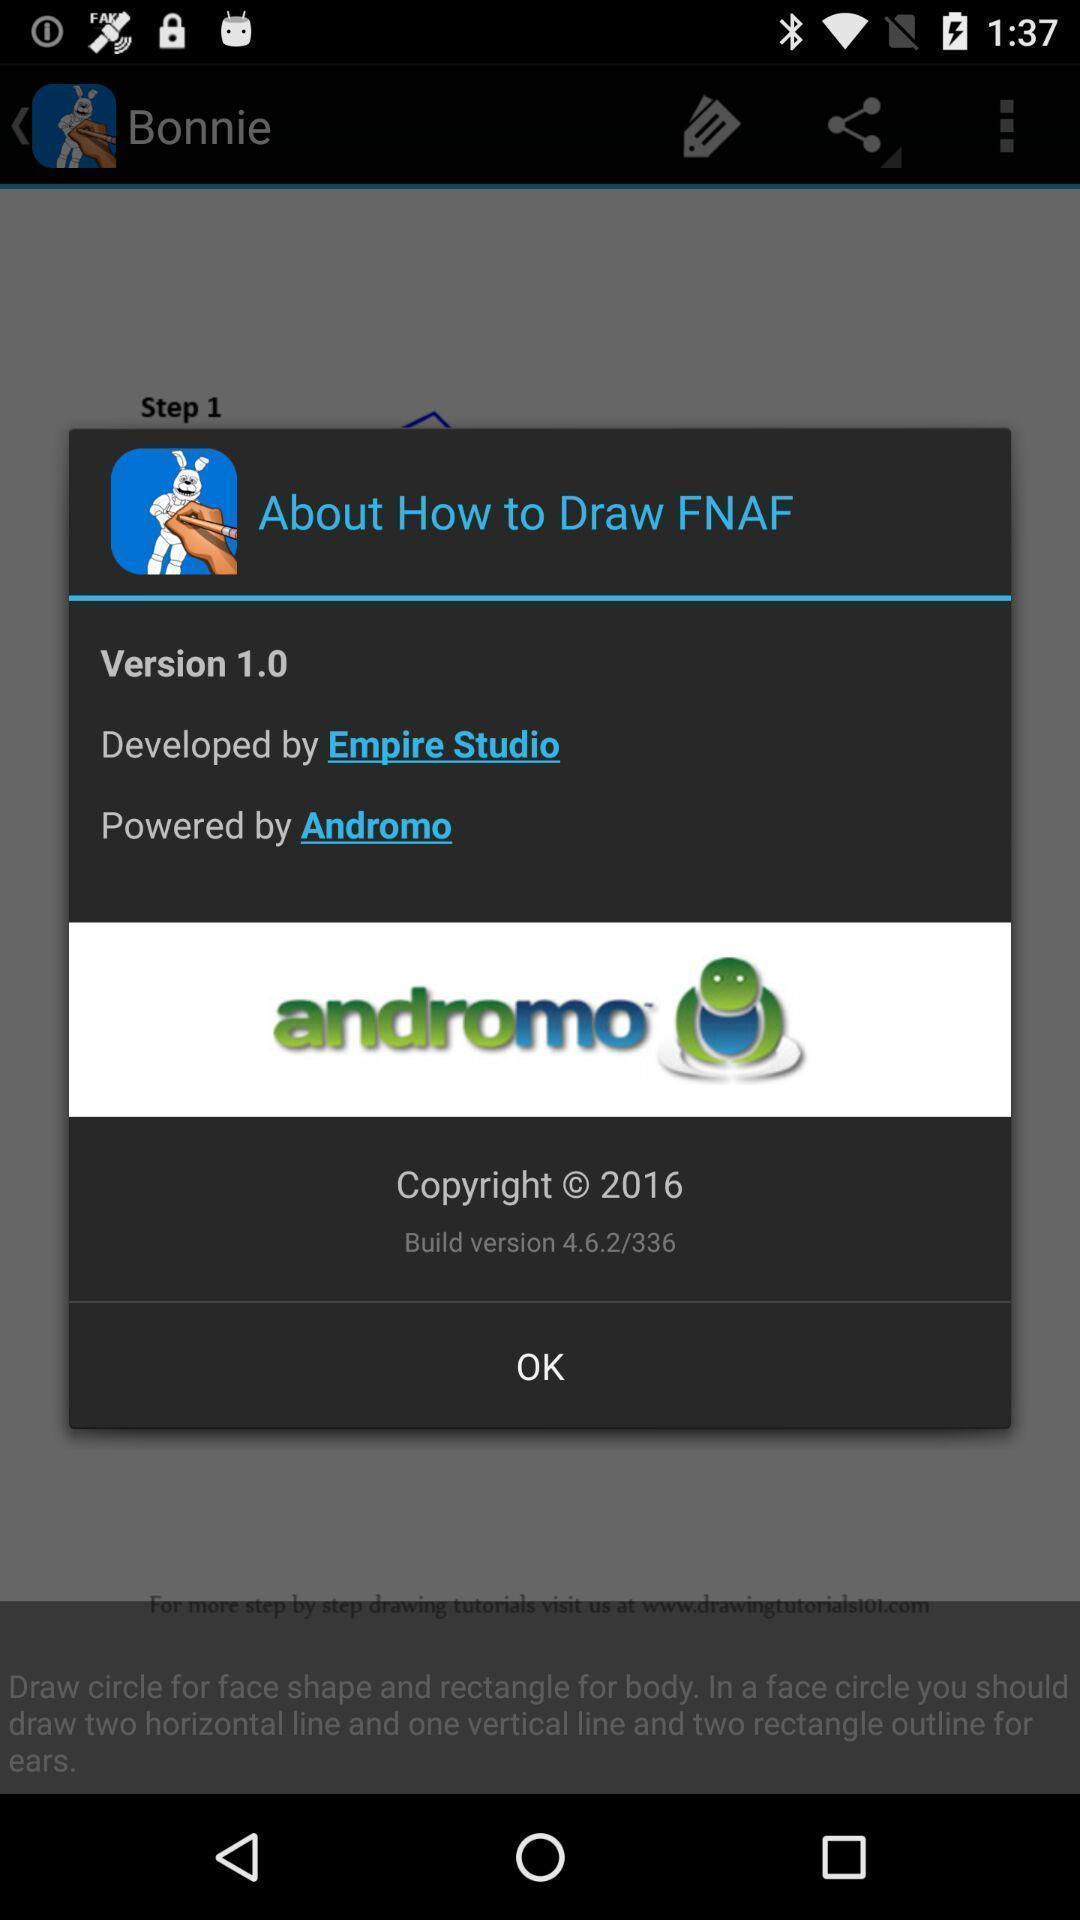Explain the elements present in this screenshot. Pop-up showing version. 